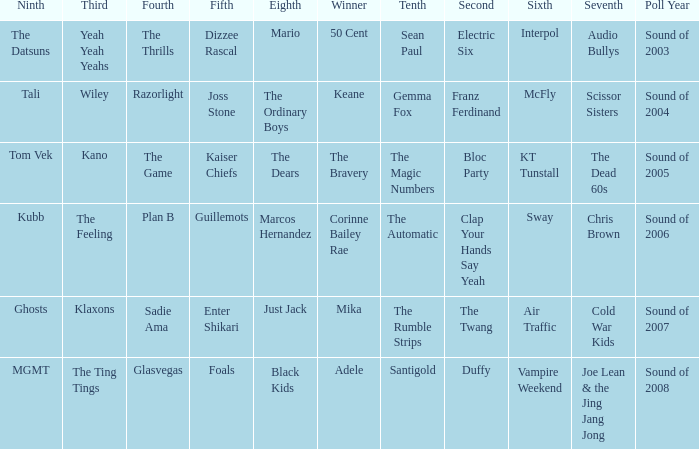When dizzee rascal is 5th, who was the winner? 50 Cent. 